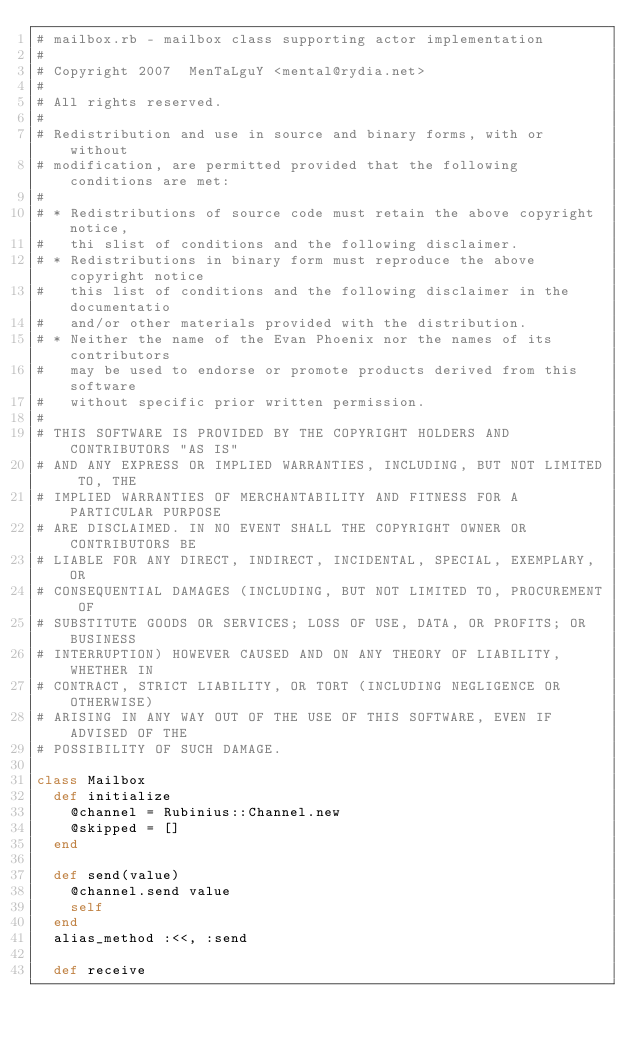Convert code to text. <code><loc_0><loc_0><loc_500><loc_500><_Ruby_># mailbox.rb - mailbox class supporting actor implementation
#
# Copyright 2007  MenTaLguY <mental@rydia.net>
#
# All rights reserved.
# 
# Redistribution and use in source and binary forms, with or without 
# modification, are permitted provided that the following conditions are met:
# 
# * Redistributions of source code must retain the above copyright notice,
#   thi slist of conditions and the following disclaimer.
# * Redistributions in binary form must reproduce the above copyright notice
#   this list of conditions and the following disclaimer in the documentatio
#   and/or other materials provided with the distribution.
# * Neither the name of the Evan Phoenix nor the names of its contributors 
#   may be used to endorse or promote products derived from this software 
#   without specific prior written permission.
# 
# THIS SOFTWARE IS PROVIDED BY THE COPYRIGHT HOLDERS AND CONTRIBUTORS "AS IS" 
# AND ANY EXPRESS OR IMPLIED WARRANTIES, INCLUDING, BUT NOT LIMITED TO, THE 
# IMPLIED WARRANTIES OF MERCHANTABILITY AND FITNESS FOR A PARTICULAR PURPOSE
# ARE DISCLAIMED. IN NO EVENT SHALL THE COPYRIGHT OWNER OR CONTRIBUTORS BE
# LIABLE FOR ANY DIRECT, INDIRECT, INCIDENTAL, SPECIAL, EXEMPLARY, OR
# CONSEQUENTIAL DAMAGES (INCLUDING, BUT NOT LIMITED TO, PROCUREMENT OF
# SUBSTITUTE GOODS OR SERVICES; LOSS OF USE, DATA, OR PROFITS; OR BUSINESS
# INTERRUPTION) HOWEVER CAUSED AND ON ANY THEORY OF LIABILITY, WHETHER IN
# CONTRACT, STRICT LIABILITY, OR TORT (INCLUDING NEGLIGENCE OR OTHERWISE)
# ARISING IN ANY WAY OUT OF THE USE OF THIS SOFTWARE, EVEN IF ADVISED OF THE
# POSSIBILITY OF SUCH DAMAGE.

class Mailbox
  def initialize
    @channel = Rubinius::Channel.new
    @skipped = []
  end

  def send(value)
    @channel.send value
    self
  end
  alias_method :<<, :send

  def receive</code> 